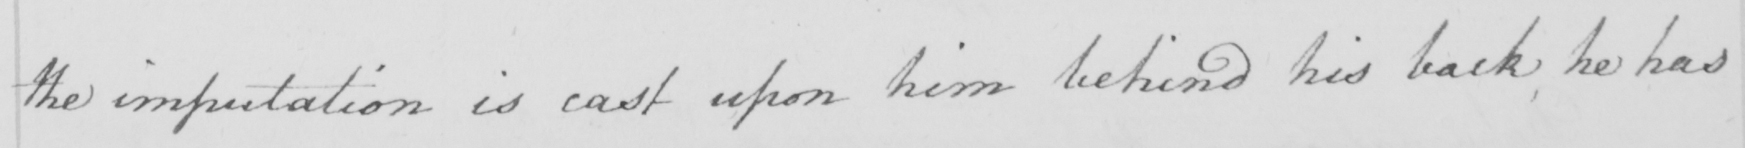Can you tell me what this handwritten text says? the imputation is cast upon him behind his back he has 